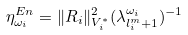<formula> <loc_0><loc_0><loc_500><loc_500>\eta ^ { E n } _ { \omega _ { i } } = \| R _ { i } \| ^ { 2 } _ { V _ { i } ^ { * } } ( \lambda _ { l ^ { m } _ { i } + 1 } ^ { \omega _ { i } } ) ^ { - 1 }</formula> 